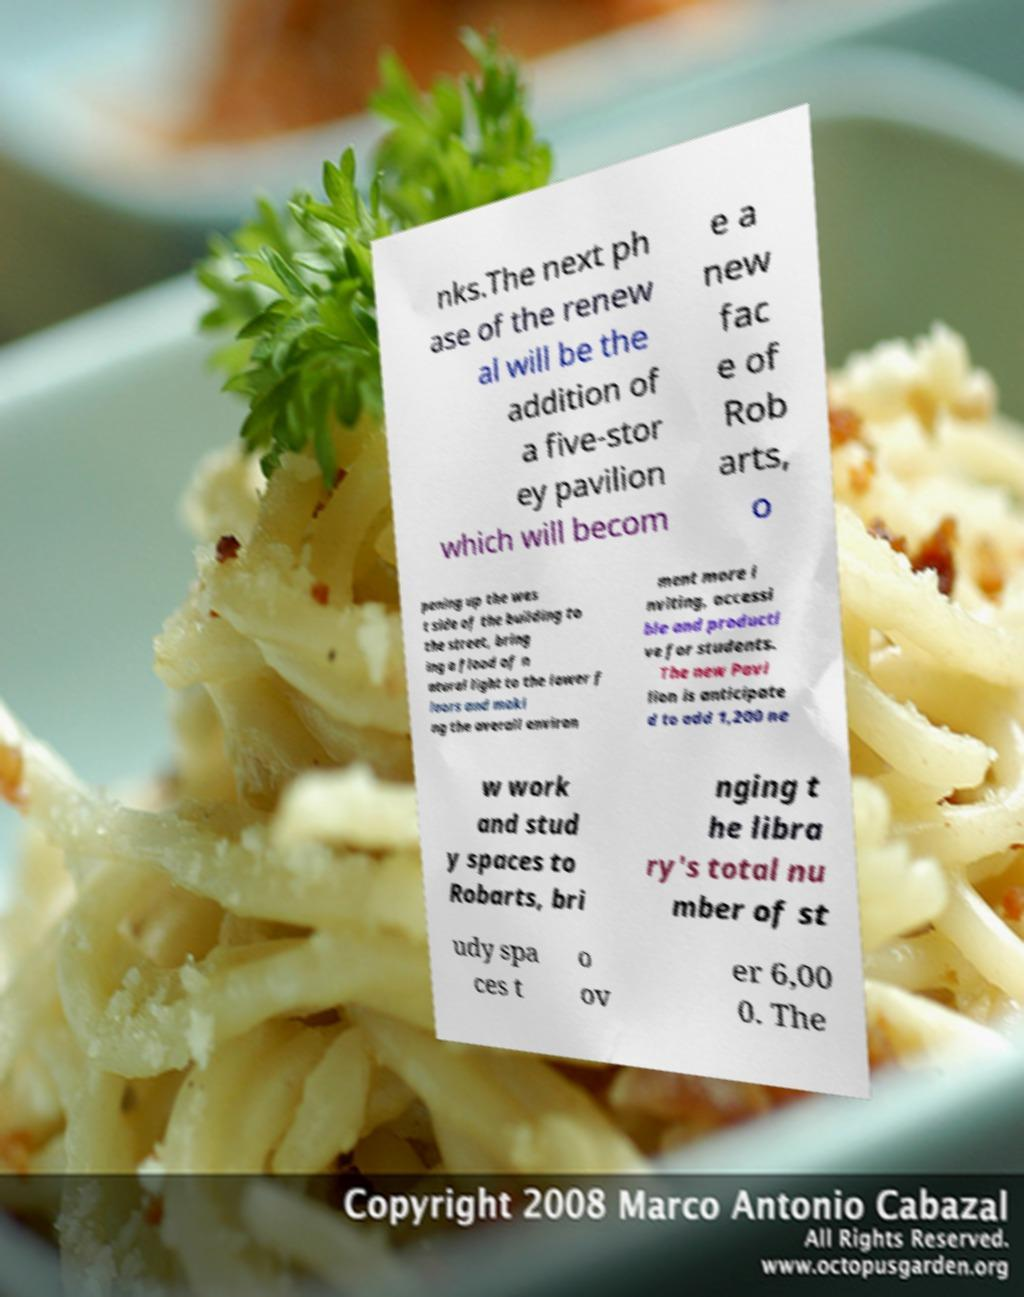Could you extract and type out the text from this image? nks.The next ph ase of the renew al will be the addition of a five-stor ey pavilion which will becom e a new fac e of Rob arts, o pening up the wes t side of the building to the street, bring ing a flood of n atural light to the lower f loors and maki ng the overall environ ment more i nviting, accessi ble and producti ve for students. The new Pavi lion is anticipate d to add 1,200 ne w work and stud y spaces to Robarts, bri nging t he libra ry's total nu mber of st udy spa ces t o ov er 6,00 0. The 